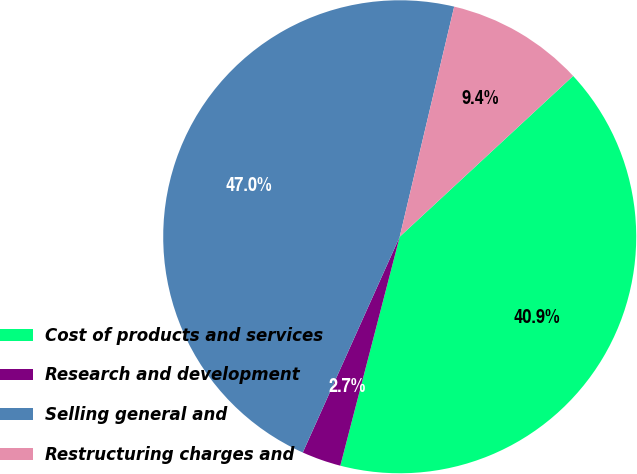Convert chart to OTSL. <chart><loc_0><loc_0><loc_500><loc_500><pie_chart><fcel>Cost of products and services<fcel>Research and development<fcel>Selling general and<fcel>Restructuring charges and<nl><fcel>40.94%<fcel>2.68%<fcel>46.98%<fcel>9.4%<nl></chart> 